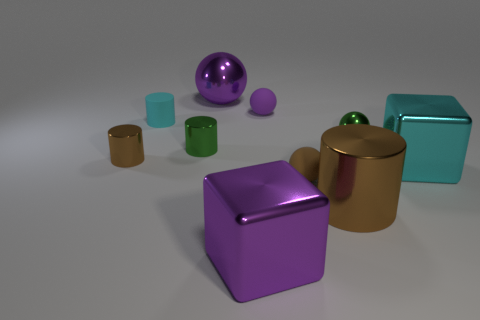There is a big thing that is the same color as the rubber cylinder; what is it made of?
Make the answer very short. Metal. The big purple metallic object that is in front of the small cyan rubber object has what shape?
Give a very brief answer. Cube. What number of other cylinders are the same size as the cyan cylinder?
Make the answer very short. 2. There is a shiny ball to the left of the tiny purple rubber object; does it have the same color as the big cylinder?
Provide a short and direct response. No. There is a sphere that is both on the left side of the big brown metal cylinder and in front of the cyan rubber thing; what material is it?
Your answer should be compact. Rubber. Is the number of big red matte cylinders greater than the number of brown metallic things?
Make the answer very short. No. The big shiny thing that is behind the small green object that is right of the purple ball on the right side of the big shiny sphere is what color?
Offer a very short reply. Purple. Is the material of the cyan thing to the left of the big cyan metallic object the same as the large cyan thing?
Provide a short and direct response. No. Are there any large metal cylinders of the same color as the big ball?
Provide a short and direct response. No. Is there a big cyan metallic thing?
Give a very brief answer. Yes. 